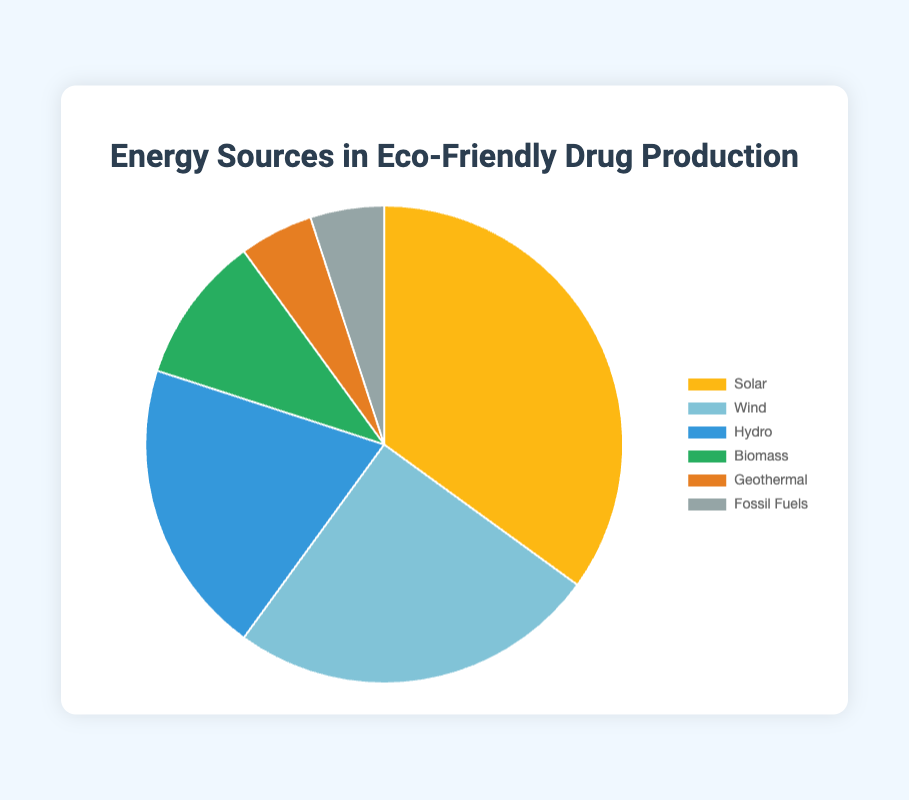What is the most utilized energy source in eco-friendly drug production? The pie chart shows the percentage breakdown of different energy sources. Solar energy is represented with the largest segment at 35%.
Answer: Solar Which energy source is used the least in eco-friendly drug production? The smallest segment in the pie chart represents Geothermal and Fossil Fuels, each at 5%.
Answer: Geothermal and Fossil Fuels How much more does Solar contribute compared to Wind? Solar contributes 35%, and Wind contributes 25%. The difference is calculated by subtracting the percentage of Wind from Solar, 35% - 25% = 10%.
Answer: 10% What is the combined percentage of Hydro and Biomass energy sources? Hydro contributes 20%, and Biomass contributes 10%. The combined percentage is the sum of these two values, 20% + 10% = 30%.
Answer: 30% What percentage of the energy sources are renewable (Solar, Wind, Hydro, Biomass, Geothermal)? Adding up the percentages of all renewable sources: Solar (35%), Wind (25%), Hydro (20%), Biomass (10%), and Geothermal (5%), we get 35% + 25% + 20% + 10% + 5% = 95%.
Answer: 95% Which energy sources together account for half of the energy used in eco-friendly drug production? The pie chart shows Solar at 35% and Wind at 25%. Combined, they account for 35% + 25% = 60%, which is more than half. To get exactly half, Solar (35%) and Hydro (20%) sum to 55%, still more than half. The closest is Solar (35%) and Biomass (10%) summing to 45%, less than half. Thus, Solar and Wind together account for slightly more than half but closely represent the answer.
Answer: Solar and Wind What is the percentage difference between the energy sources contributing the least and the most used? The most used energy source is Solar at 35% and the least used are Geothermal and Fossil Fuels, each at 5%. The difference is calculated as 35% - 5% = 30%.
Answer: 30% How do the contributions of Biomass and Geothermal compare? Biomass contributes 10%, and Geothermal contributes 5%. Biomass contributes 10% - 5% = 5% more than Geothermal.
Answer: Biomass contributes 5% more How much less does Hydro contribute compared to Solar? Hydro contributes 20%, and Solar contributes 35%. The difference is 35% - 20% = 15%.
Answer: 15% 